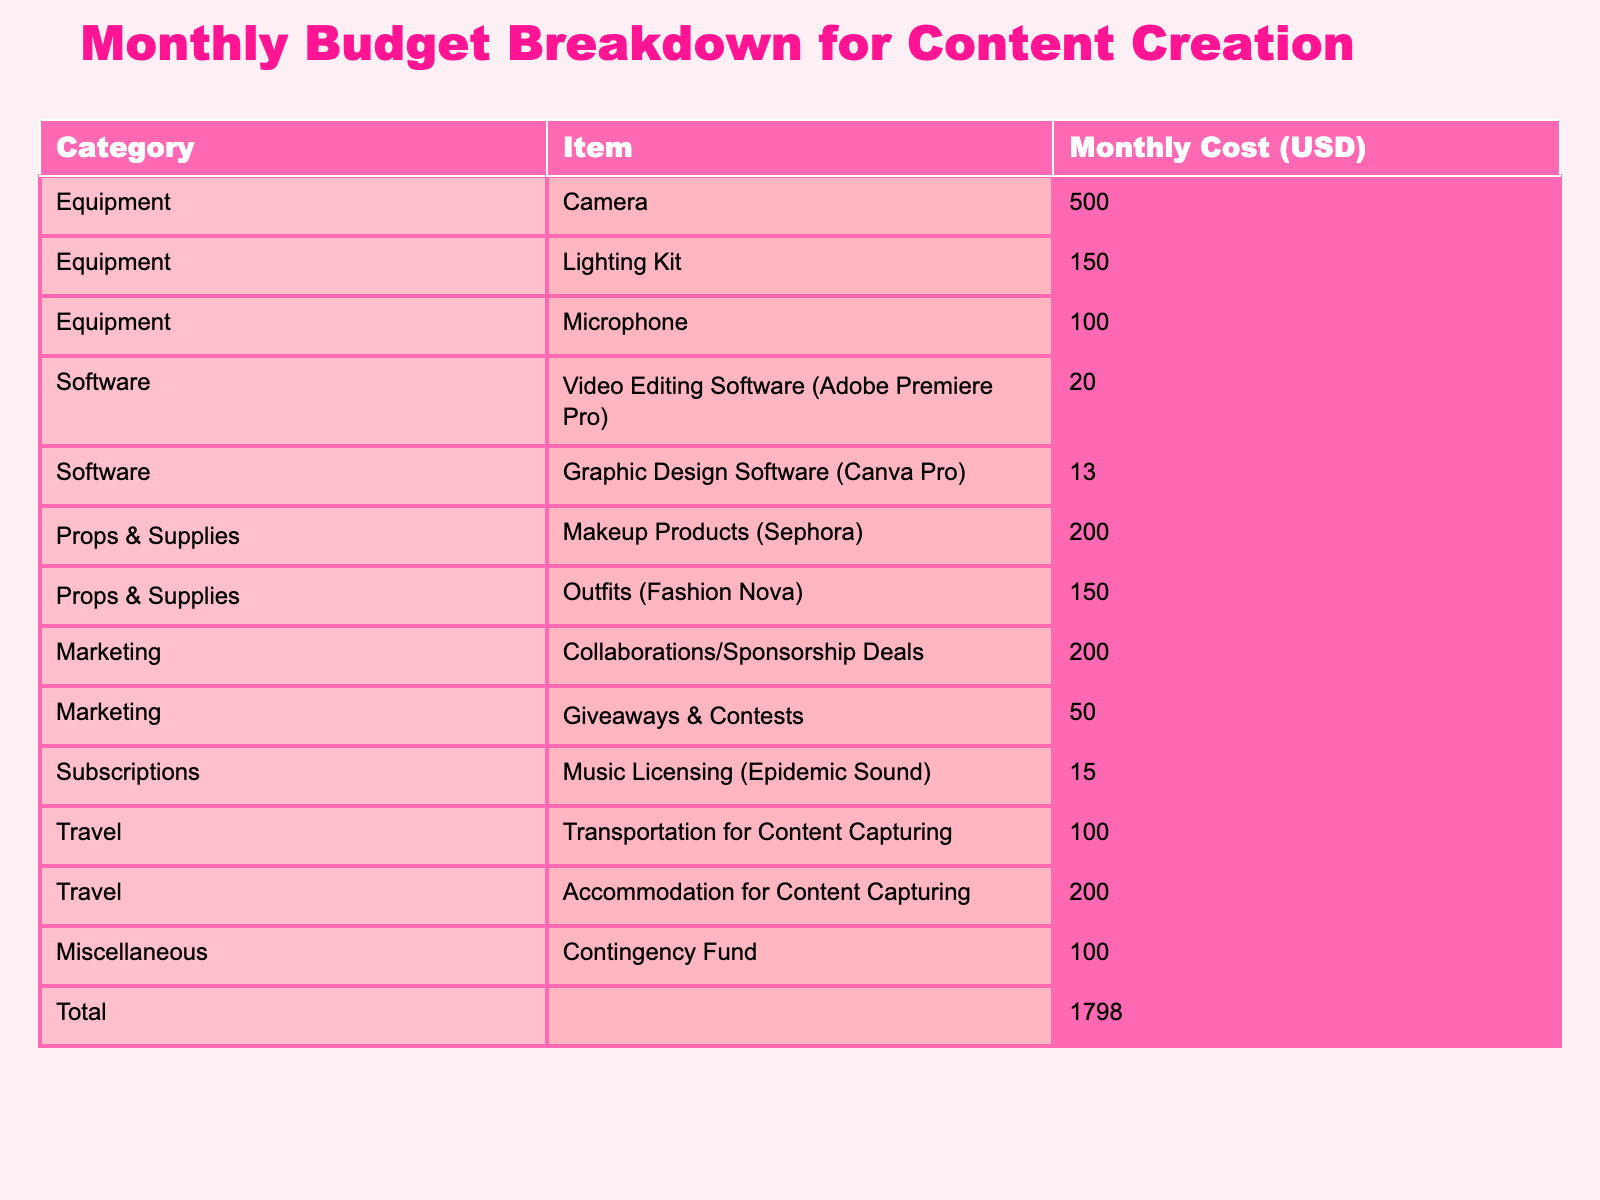What is the total monthly cost for content creation activities? The total monthly cost is found at the bottom of the table under the 'Total' row. By summing up all individual monthly costs (500 + 150 + 100 + 20 + 13 + 200 + 150 + 200 + 50 + 15 + 100 + 200 + 100), the result is 1,800.
Answer: 1800 How much is spent on equipment each month? To find the monthly spending on equipment, we focus on the 'Equipment' category and sum its costs: (500 + 150 + 100) = 750.
Answer: 750 Is the cost for giveaways and contests more than the cost for music licensing? We compare the two costs listed in the table: the cost for giveaways and contests is 50, while the cost for music licensing is 15. Since 50 is greater than 15, the statement is true.
Answer: Yes What is the average monthly cost for props and supplies? The 'Props & Supplies' category has two items: Makeup Products (200) and Outfits (150). To find the average, we sum these costs (200 + 150 = 350) and then divide by the number of items (2). So, the average is 350/2 = 175.
Answer: 175 How much more is spent on travel compared to marketing? First, we calculate the total travel costs: Transportation (100) + Accommodation (200) = 300. Then we calculate the total marketing costs: Collaborations (200) + Giveaways (50) = 250. Therefore, the difference is 300 - 250 = 50.
Answer: 50 What percentage of the total budget is allocated to props and supplies? The total cost for props and supplies is 350 (200 for makeup + 150 for outfits). The overall budget is 1800. To find the percentage, we compute (350/1800) * 100, which equals approximately 19.44%.
Answer: 19.44% Are monthly costs for software greater than those for props and supplies? The total cost for software is 33 (20 for video editing + 13 for graphic design), while the total for props and supplies is 350. Since 33 is less than 350, the statement is false.
Answer: No What is the combined total for subscriptions and miscellaneous costs? We add the costs for subscriptions (15 for music licensing) and miscellaneous (100 for contingency). The combined total is 15 + 100 = 115.
Answer: 115 